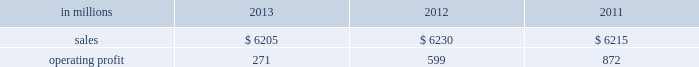Million excluding a gain on a bargain purchase price adjustment on the acquisition of a majority share of our operations in turkey and restructuring costs ) compared with $ 53 million ( $ 72 million excluding restructuring costs ) in 2012 and $ 66 million ( $ 61 million excluding a gain for a bargain purchase price adjustment on an acquisition by our then joint venture in turkey and costs associated with the closure of our etienne mill in france in 2009 ) in 2011 .
Sales volumes in 2013 were higher than in 2012 reflecting strong demand for packaging in the agricultural markets in morocco and turkey .
In europe , sales volumes decreased slightly due to continuing weak demand for packaging in the industrial markets , and lower demand for packaging in the agricultural markets resulting from poor weather conditions .
Average sales margins were significantly lower due to input costs for containerboard rising ahead of box sales price increases .
Other input costs were also higher , primarily for energy .
Operating profits in 2013 and 2012 included net gains of $ 13 million and $ 10 million , respectively , for insurance settlements and italian government grants , partially offset by additional operating costs , related to the earthquakes in northern italy in may 2012 which affected our san felice box plant .
Entering the first quarter of 2014 , sales volumes are expected to increase slightly reflecting higher demand for packaging in the industrial markets .
Average sales margins are expected to gradually improve as a result of slight reductions in material costs and planned box price increases .
Other input costs should be about flat .
Brazilian industrial packaging includes the results of orsa international paper embalagens s.a. , a corrugated packaging producer in which international paper acquired a 75% ( 75 % ) share in january 2013 .
Net sales were $ 335 million in 2013 .
Operating profits in 2013 were a loss of $ 2 million ( a gain of $ 2 million excluding acquisition and integration costs ) .
Looking ahead to the first quarter of 2014 , sales volumes are expected to be seasonally lower than in the fourth quarter of 2013 .
Average sales margins should improve reflecting the partial implementation of an announced sales price increase and a more favorable product mix .
Operating costs and input costs are expected to be lower .
Asian industrial packaging net sales were $ 400 million in 2013 compared with $ 400 million in 2012 and $ 410 million in 2011 .
Operating profits for the packaging operations were a loss of $ 5 million in 2013 ( a loss of $ 1 million excluding restructuring costs ) compared with gains of $ 2 million in 2012 and $ 2 million in 2011 .
Operating profits were favorably impacted in 2013 by higher average sales margins and slightly higher sales volumes compared with 2012 , but these benefits were offset by higher operating costs .
Looking ahead to the first quarter of 2014 , sales volumes and average sales margins are expected to be seasonally soft .
Net sales for the distribution operations were $ 285 million in 2013 compared with $ 260 million in 2012 and $ 285 million in 2011 .
Operating profits were $ 3 million in 2013 , 2012 and 2011 .
Printing papers demand for printing papers products is closely correlated with changes in commercial printing and advertising activity , direct mail volumes and , for uncoated cut-size products , with changes in white- collar employment levels that affect the usage of copy and laser printer paper .
Pulp is further affected by changes in currency rates that can enhance or disadvantage producers in different geographic regions .
Principal cost drivers include manufacturing efficiency , raw material and energy costs and freight costs .
Printing papers net sales for 2013 were about flat with both 2012 and 2011 .
Operating profits in 2013 were 55% ( 55 % ) lower than in 2012 and 69% ( 69 % ) lower than in 2011 .
Excluding facility closure costs and impairment costs , operating profits in 2013 were 15% ( 15 % ) lower than in 2012 and 40% ( 40 % ) lower than in 2011 .
Benefits from lower operating costs ( $ 81 million ) and lower maintenance outage costs ( $ 17 million ) were more than offset by lower average sales price realizations ( $ 38 million ) , lower sales volumes ( $ 14 million ) , higher input costs ( $ 99 million ) and higher other costs ( $ 34 million ) .
In addition , operating profits in 2013 included costs of $ 118 million associated with the announced closure of our courtland , alabama mill .
During 2013 , the company accelerated depreciation for certain courtland assets , and diligently evaluated certain other assets for possible alternative uses by one of our other businesses .
The net book value of these assets at december 31 , 2013 was approximately $ 470 million .
During 2014 , we have continued our evaluation and expect to conclude as to any uses for these assets during the first quarter of 2014 .
Operating profits also included a $ 123 million impairment charge associated with goodwill and a trade name intangible asset in our india papers business .
Operating profits in 2011 included a $ 24 million gain related to the announced repurposing of our franklin , virginia mill to produce fluff pulp and an $ 11 million impairment charge related to our inverurie , scotland mill that was closed in 2009 .
Printing papers .
North american printing papers net sales were $ 2.6 billion in 2013 , $ 2.7 billion in 2012 and $ 2.8 billion in 2011. .
What was the profit margin in 2011? 
Computations: (872 / 6215)
Answer: 0.14031. 